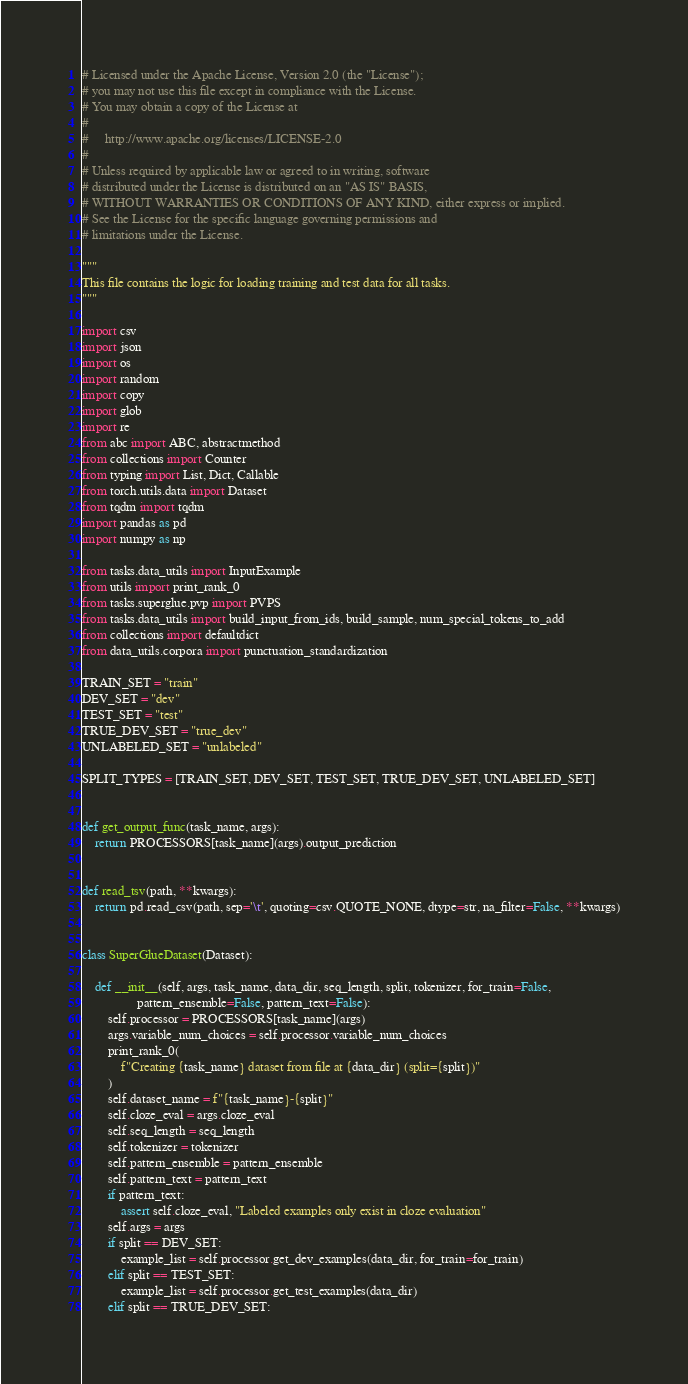Convert code to text. <code><loc_0><loc_0><loc_500><loc_500><_Python_># Licensed under the Apache License, Version 2.0 (the "License");
# you may not use this file except in compliance with the License.
# You may obtain a copy of the License at
#
#     http://www.apache.org/licenses/LICENSE-2.0
#
# Unless required by applicable law or agreed to in writing, software
# distributed under the License is distributed on an "AS IS" BASIS,
# WITHOUT WARRANTIES OR CONDITIONS OF ANY KIND, either express or implied.
# See the License for the specific language governing permissions and
# limitations under the License.

"""
This file contains the logic for loading training and test data for all tasks.
"""

import csv
import json
import os
import random
import copy
import glob
import re
from abc import ABC, abstractmethod
from collections import Counter
from typing import List, Dict, Callable
from torch.utils.data import Dataset
from tqdm import tqdm
import pandas as pd
import numpy as np

from tasks.data_utils import InputExample
from utils import print_rank_0
from tasks.superglue.pvp import PVPS
from tasks.data_utils import build_input_from_ids, build_sample, num_special_tokens_to_add
from collections import defaultdict
from data_utils.corpora import punctuation_standardization

TRAIN_SET = "train"
DEV_SET = "dev"
TEST_SET = "test"
TRUE_DEV_SET = "true_dev"
UNLABELED_SET = "unlabeled"

SPLIT_TYPES = [TRAIN_SET, DEV_SET, TEST_SET, TRUE_DEV_SET, UNLABELED_SET]


def get_output_func(task_name, args):
    return PROCESSORS[task_name](args).output_prediction


def read_tsv(path, **kwargs):
    return pd.read_csv(path, sep='\t', quoting=csv.QUOTE_NONE, dtype=str, na_filter=False, **kwargs)


class SuperGlueDataset(Dataset):

    def __init__(self, args, task_name, data_dir, seq_length, split, tokenizer, for_train=False,
                 pattern_ensemble=False, pattern_text=False):
        self.processor = PROCESSORS[task_name](args)
        args.variable_num_choices = self.processor.variable_num_choices
        print_rank_0(
            f"Creating {task_name} dataset from file at {data_dir} (split={split})"
        )
        self.dataset_name = f"{task_name}-{split}"
        self.cloze_eval = args.cloze_eval
        self.seq_length = seq_length
        self.tokenizer = tokenizer
        self.pattern_ensemble = pattern_ensemble
        self.pattern_text = pattern_text
        if pattern_text:
            assert self.cloze_eval, "Labeled examples only exist in cloze evaluation"
        self.args = args
        if split == DEV_SET:
            example_list = self.processor.get_dev_examples(data_dir, for_train=for_train)
        elif split == TEST_SET:
            example_list = self.processor.get_test_examples(data_dir)
        elif split == TRUE_DEV_SET:</code> 